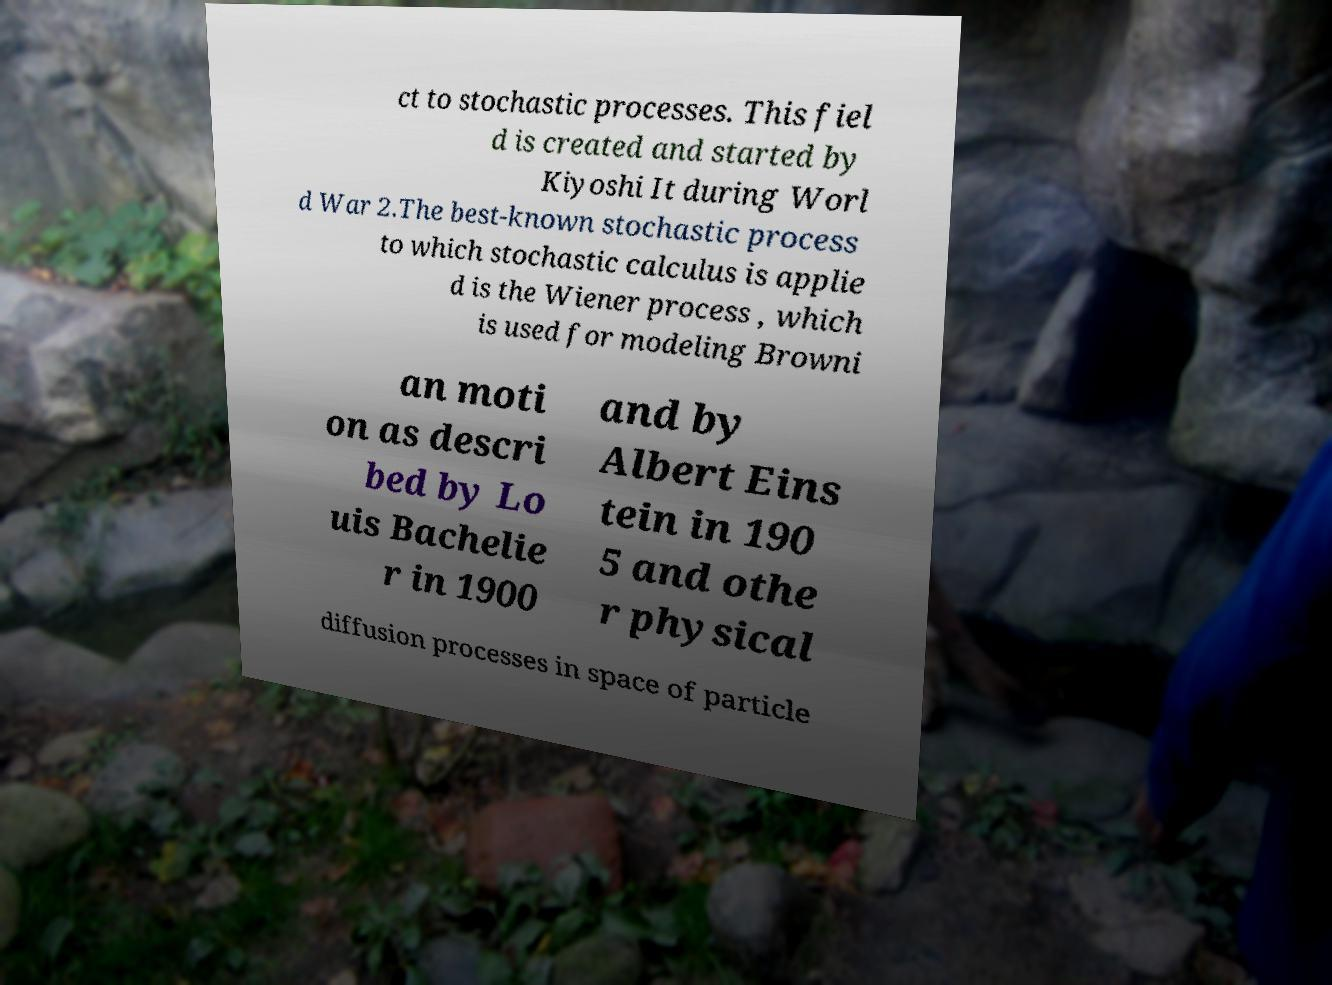Could you extract and type out the text from this image? ct to stochastic processes. This fiel d is created and started by Kiyoshi It during Worl d War 2.The best-known stochastic process to which stochastic calculus is applie d is the Wiener process , which is used for modeling Browni an moti on as descri bed by Lo uis Bachelie r in 1900 and by Albert Eins tein in 190 5 and othe r physical diffusion processes in space of particle 